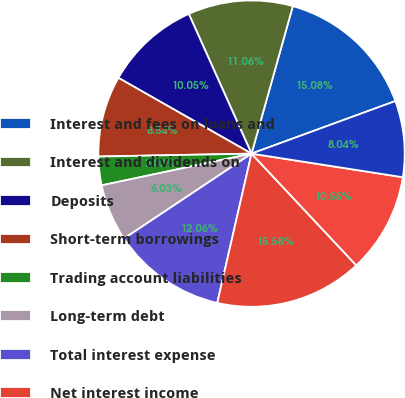Convert chart. <chart><loc_0><loc_0><loc_500><loc_500><pie_chart><fcel>Interest and fees on loans and<fcel>Interest and dividends on<fcel>Deposits<fcel>Short-term borrowings<fcel>Trading account liabilities<fcel>Long-term debt<fcel>Total interest expense<fcel>Net interest income<fcel>Servicecharges<fcel>Investment and brokerage<nl><fcel>15.08%<fcel>11.06%<fcel>10.05%<fcel>8.54%<fcel>3.02%<fcel>6.03%<fcel>12.06%<fcel>15.58%<fcel>10.55%<fcel>8.04%<nl></chart> 